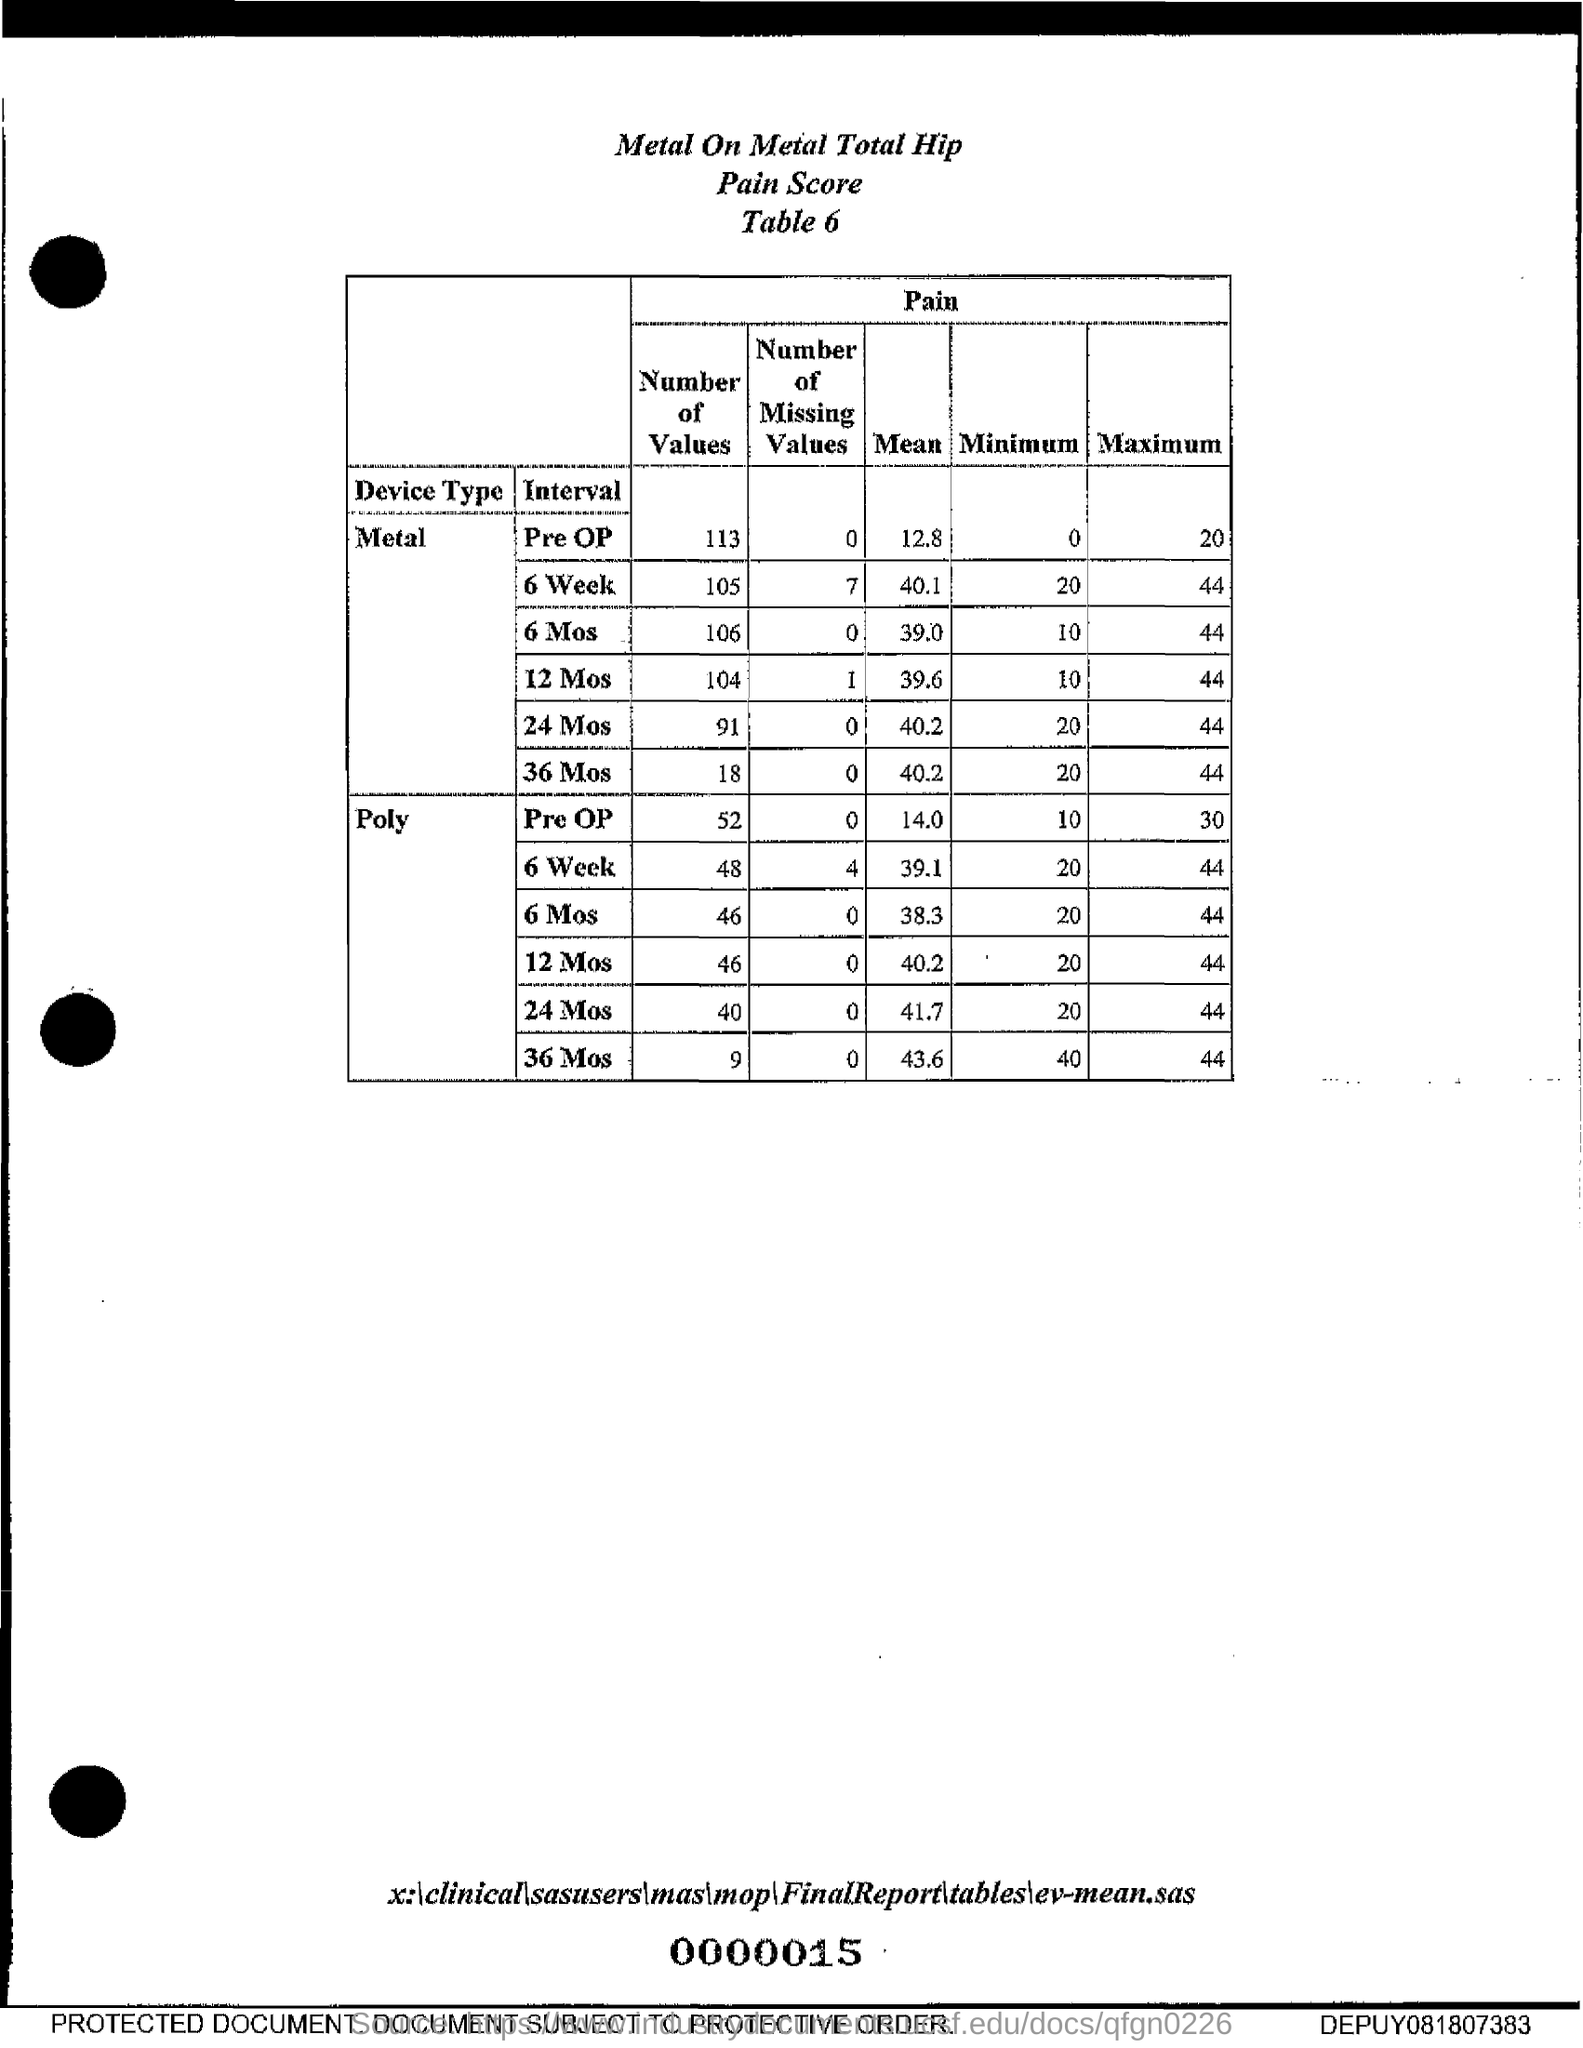Identify some key points in this picture. The mean for metal 6 is 40.1. The mean for metal 12 MoS is 39.6. The mean score for Poly for 6 weeks is 39.1. The mean score for Poly for 6 months is 38.3. The mean for metal 6 months is 39.0. 